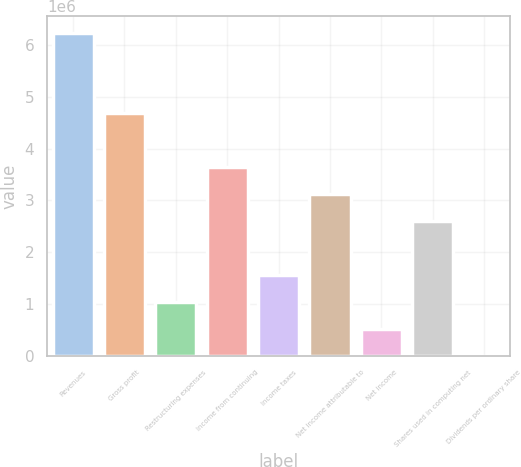Convert chart. <chart><loc_0><loc_0><loc_500><loc_500><bar_chart><fcel>Revenues<fcel>Gross profit<fcel>Restructuring expenses<fcel>Income from continuing<fcel>Income taxes<fcel>Net income attributable to<fcel>Net income<fcel>Shares used in computing net<fcel>Dividends per ordinary share<nl><fcel>6.2404e+06<fcel>4.6803e+06<fcel>1.04007e+06<fcel>3.64023e+06<fcel>1.5601e+06<fcel>3.1202e+06<fcel>520034<fcel>2.60017e+06<fcel>1.21<nl></chart> 